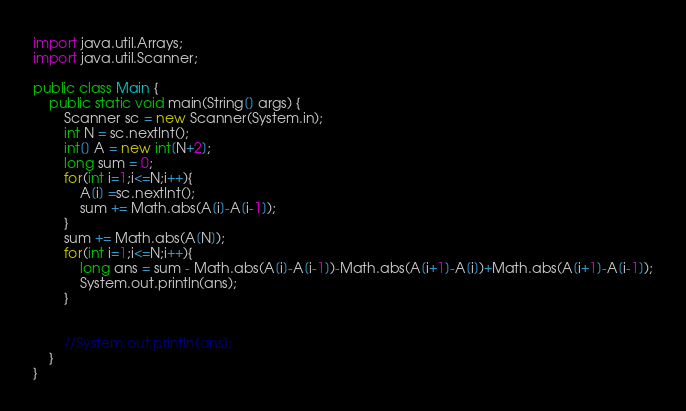Convert code to text. <code><loc_0><loc_0><loc_500><loc_500><_Java_>import java.util.Arrays;
import java.util.Scanner;

public class Main {
    public static void main(String[] args) {
        Scanner sc = new Scanner(System.in);
        int N = sc.nextInt();
        int[] A = new int[N+2];
        long sum = 0;
        for(int i=1;i<=N;i++){
            A[i] =sc.nextInt();
            sum += Math.abs(A[i]-A[i-1]);
        }
        sum += Math.abs(A[N]);
        for(int i=1;i<=N;i++){
            long ans = sum - Math.abs(A[i]-A[i-1])-Math.abs(A[i+1]-A[i])+Math.abs(A[i+1]-A[i-1]);
            System.out.println(ans);
        }


        //System.out.println(ans);
    }
}
</code> 